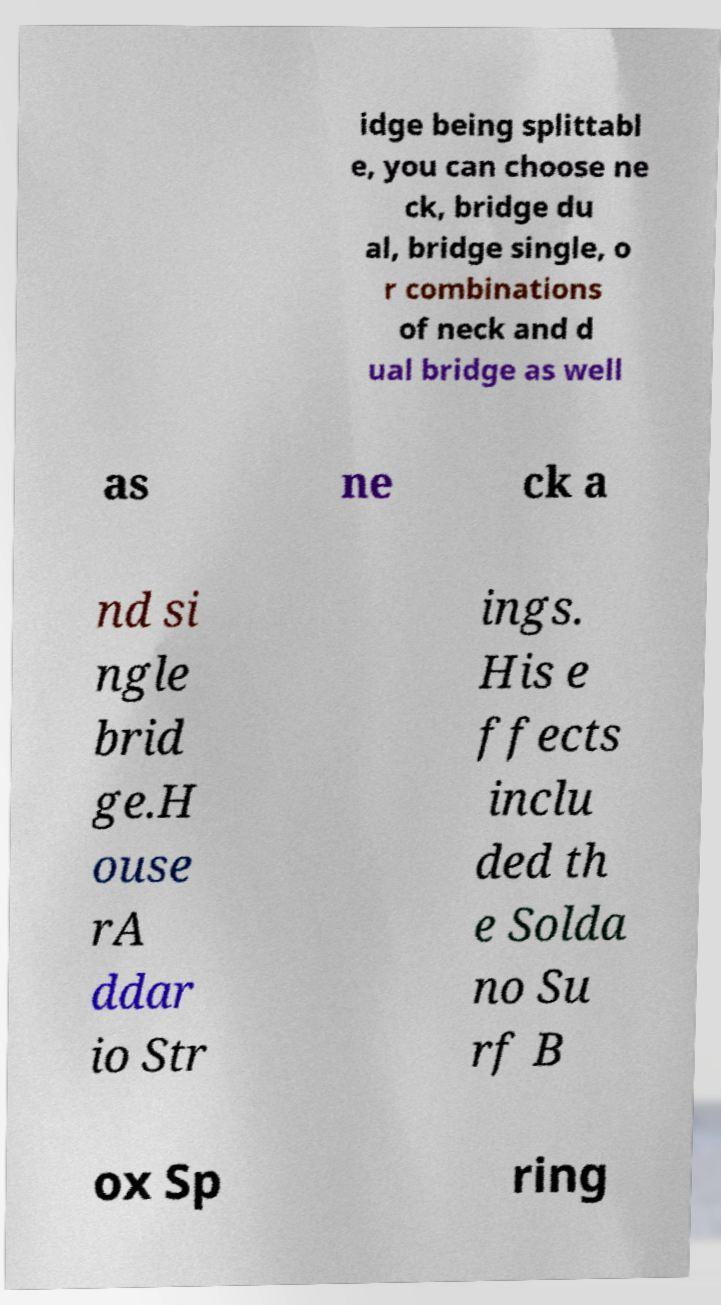Can you accurately transcribe the text from the provided image for me? idge being splittabl e, you can choose ne ck, bridge du al, bridge single, o r combinations of neck and d ual bridge as well as ne ck a nd si ngle brid ge.H ouse rA ddar io Str ings. His e ffects inclu ded th e Solda no Su rf B ox Sp ring 